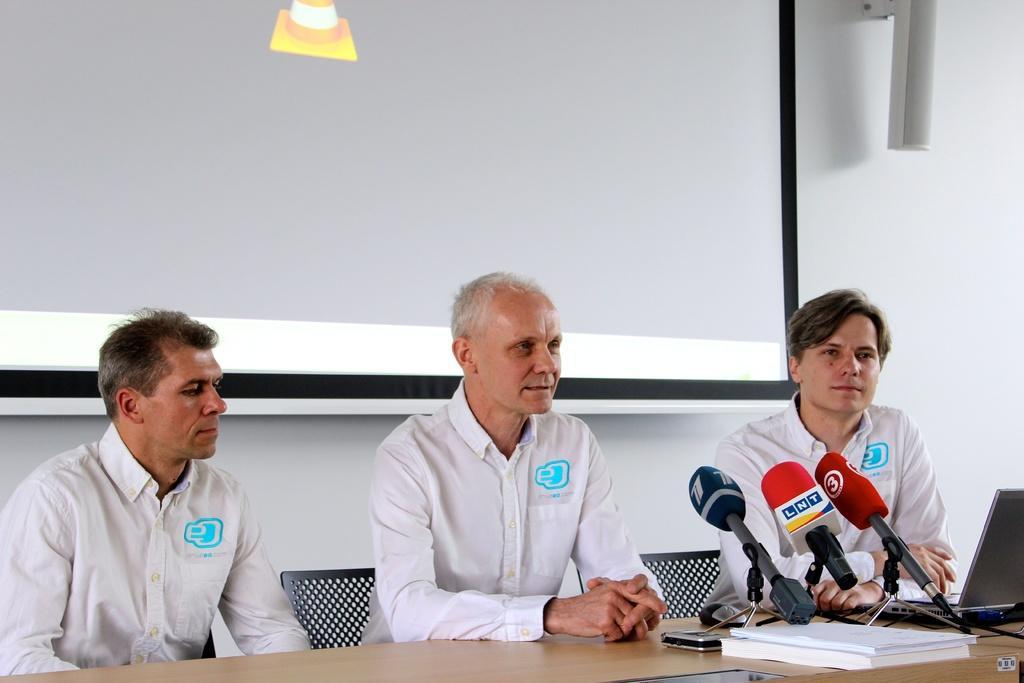In one or two sentences, can you explain what this image depicts? In this picture we can see three men are sitting on chairs in front of a table, there is a laptop, three microphones and two books present on the table, in the background there is a wall, we can see a screen on the left side, it looks like a speaker on the right side. 